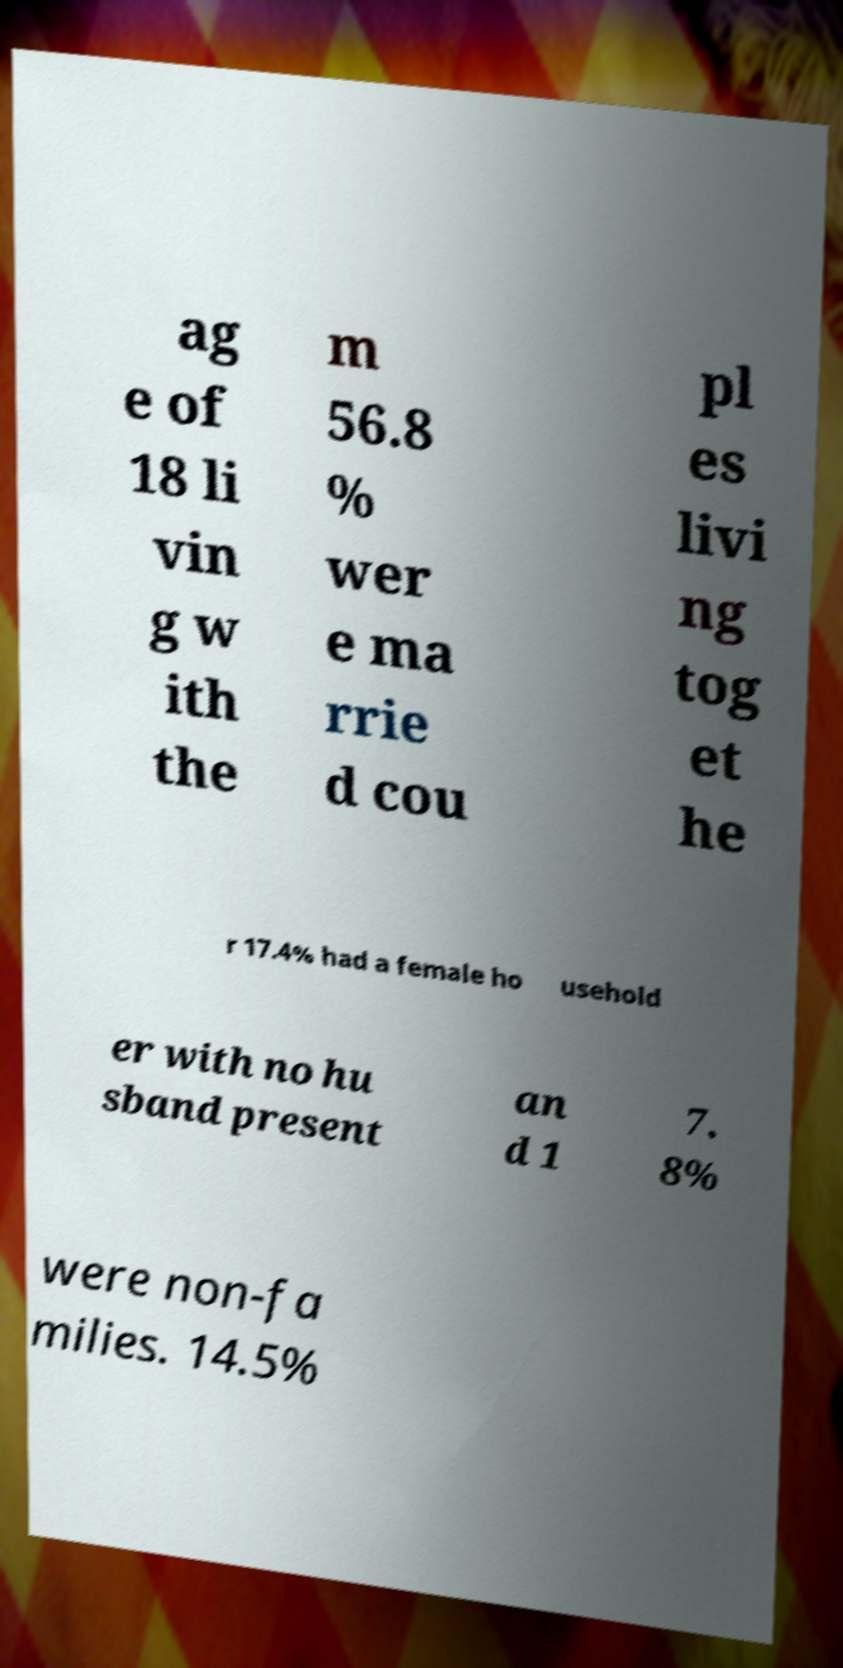Can you read and provide the text displayed in the image?This photo seems to have some interesting text. Can you extract and type it out for me? ag e of 18 li vin g w ith the m 56.8 % wer e ma rrie d cou pl es livi ng tog et he r 17.4% had a female ho usehold er with no hu sband present an d 1 7. 8% were non-fa milies. 14.5% 